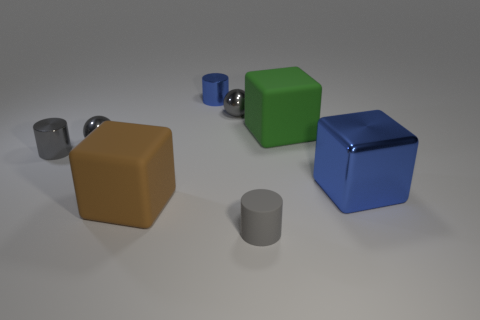Subtract all tiny blue shiny cylinders. How many cylinders are left? 2 Subtract 1 balls. How many balls are left? 1 Add 2 tiny blue balls. How many objects exist? 10 Subtract all purple cubes. How many gray cylinders are left? 2 Subtract all gray cylinders. How many cylinders are left? 1 Subtract all blocks. How many objects are left? 5 Subtract all tiny matte things. Subtract all blue cylinders. How many objects are left? 6 Add 3 green objects. How many green objects are left? 4 Add 1 metallic things. How many metallic things exist? 6 Subtract 0 yellow cylinders. How many objects are left? 8 